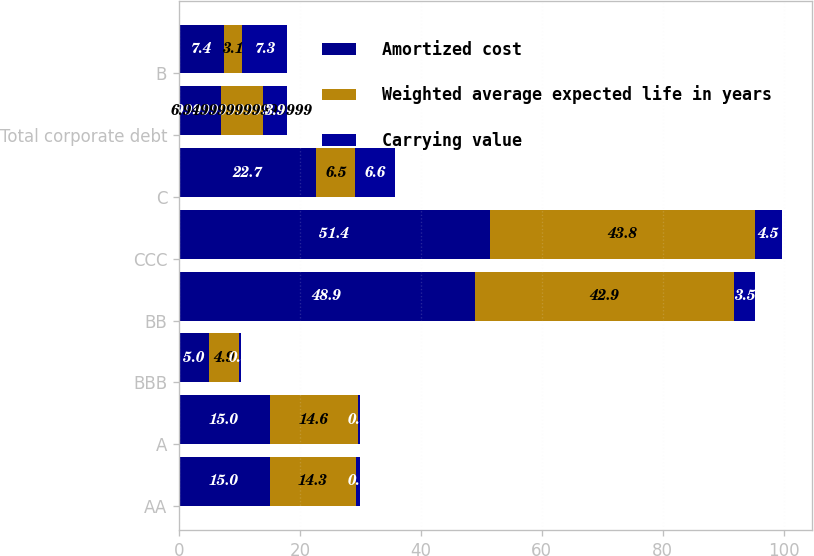Convert chart. <chart><loc_0><loc_0><loc_500><loc_500><stacked_bar_chart><ecel><fcel>AA<fcel>A<fcel>BBB<fcel>BB<fcel>CCC<fcel>C<fcel>Total corporate debt<fcel>B<nl><fcel>Amortized cost<fcel>15<fcel>15<fcel>5<fcel>48.9<fcel>51.4<fcel>22.7<fcel>6.95<fcel>7.4<nl><fcel>Weighted average expected life in years<fcel>14.3<fcel>14.6<fcel>4.9<fcel>42.9<fcel>43.8<fcel>6.5<fcel>6.95<fcel>3.1<nl><fcel>Carrying value<fcel>0.7<fcel>0.3<fcel>0.3<fcel>3.5<fcel>4.5<fcel>6.6<fcel>3.9<fcel>7.3<nl></chart> 